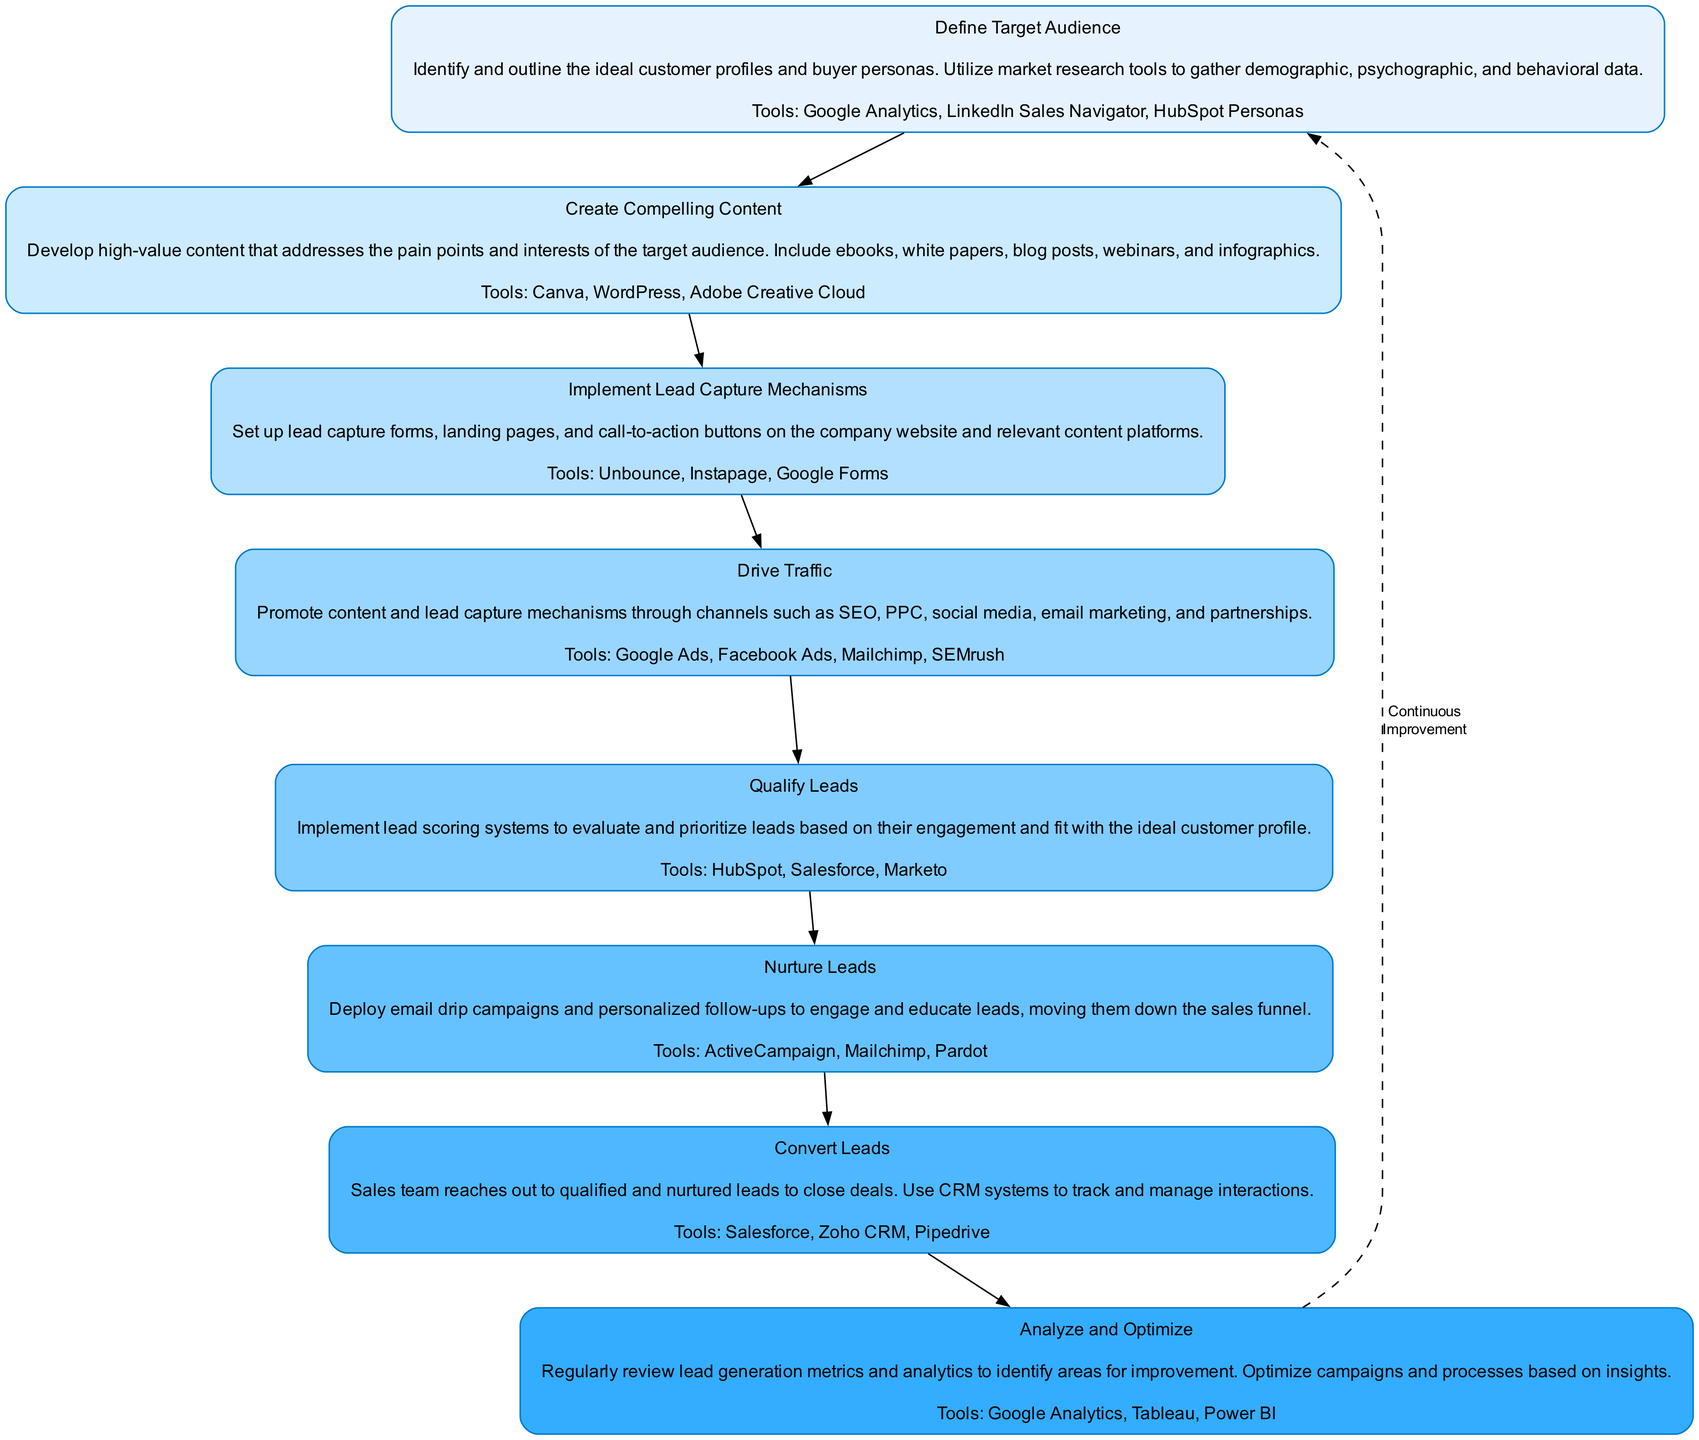What is the first step in the lead generation process? The diagram begins with the step labeled "Define Target Audience," which is the first node.
Answer: Define Target Audience How many total steps are in the lead generation process? The diagram shows eight distinct steps outlined as nodes.
Answer: 8 What is the last step before "Analyze and Optimize"? The last step before "Analyze and Optimize" is "Convert Leads," which directly precedes it.
Answer: Convert Leads Which tool is mentioned in the "Create Compelling Content" step? In the "Create Compelling Content" step, "Canva" is one of the tools referenced for content creation.
Answer: Canva What type of mechanism is implemented in step 3? Step 3 focuses on implementing lead capture mechanisms, which are essential for gathering leads.
Answer: Lead Capture Mechanisms What is the relationship between the "Drive Traffic" step and the following step? The "Drive Traffic" step precedes "Qualify Leads," indicating that driving traffic helps generate leads that will be qualified in the next step.
Answer: Precedes How does the flow of the diagram indicate continuous improvement? The dashed edge labeled "Continuous Improvement" connects the last step back to the first step, indicating an ongoing cycle of optimization.
Answer: Continuous Improvement Which step involves the use of CRM systems? The step "Convert Leads" mentions the use of CRM systems to track and manage interactions with leads.
Answer: Convert Leads What is the primary goal of the "Nurture Leads" step? The primary goal of the "Nurture Leads" step is to engage and educate leads through personalized follow-ups.
Answer: Engage and Educate Leads Which step utilizes lead scoring systems? The "Qualify Leads" step is where lead scoring systems are implemented to prioritize leads based on their engagement level.
Answer: Qualify Leads 